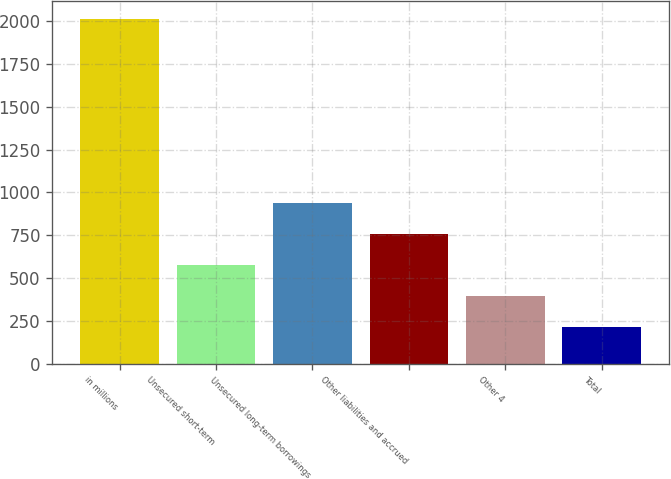<chart> <loc_0><loc_0><loc_500><loc_500><bar_chart><fcel>in millions<fcel>Unsecured short-term<fcel>Unsecured long-term borrowings<fcel>Other liabilities and accrued<fcel>Other 4<fcel>Total<nl><fcel>2015<fcel>575.8<fcel>935.6<fcel>755.7<fcel>395.9<fcel>216<nl></chart> 